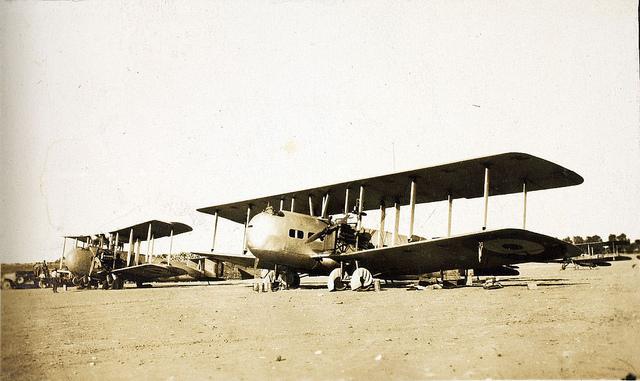Are these modern aircraft or antique aircraft?
Quick response, please. Antique. Is this an African village?
Answer briefly. No. Where is the airplane parked?
Concise answer only. Dirt. How many planes are here?
Quick response, please. 2. How many struts are on the plane?
Be succinct. 16. What does it say on the plane on the left side?
Give a very brief answer. Nothing. 